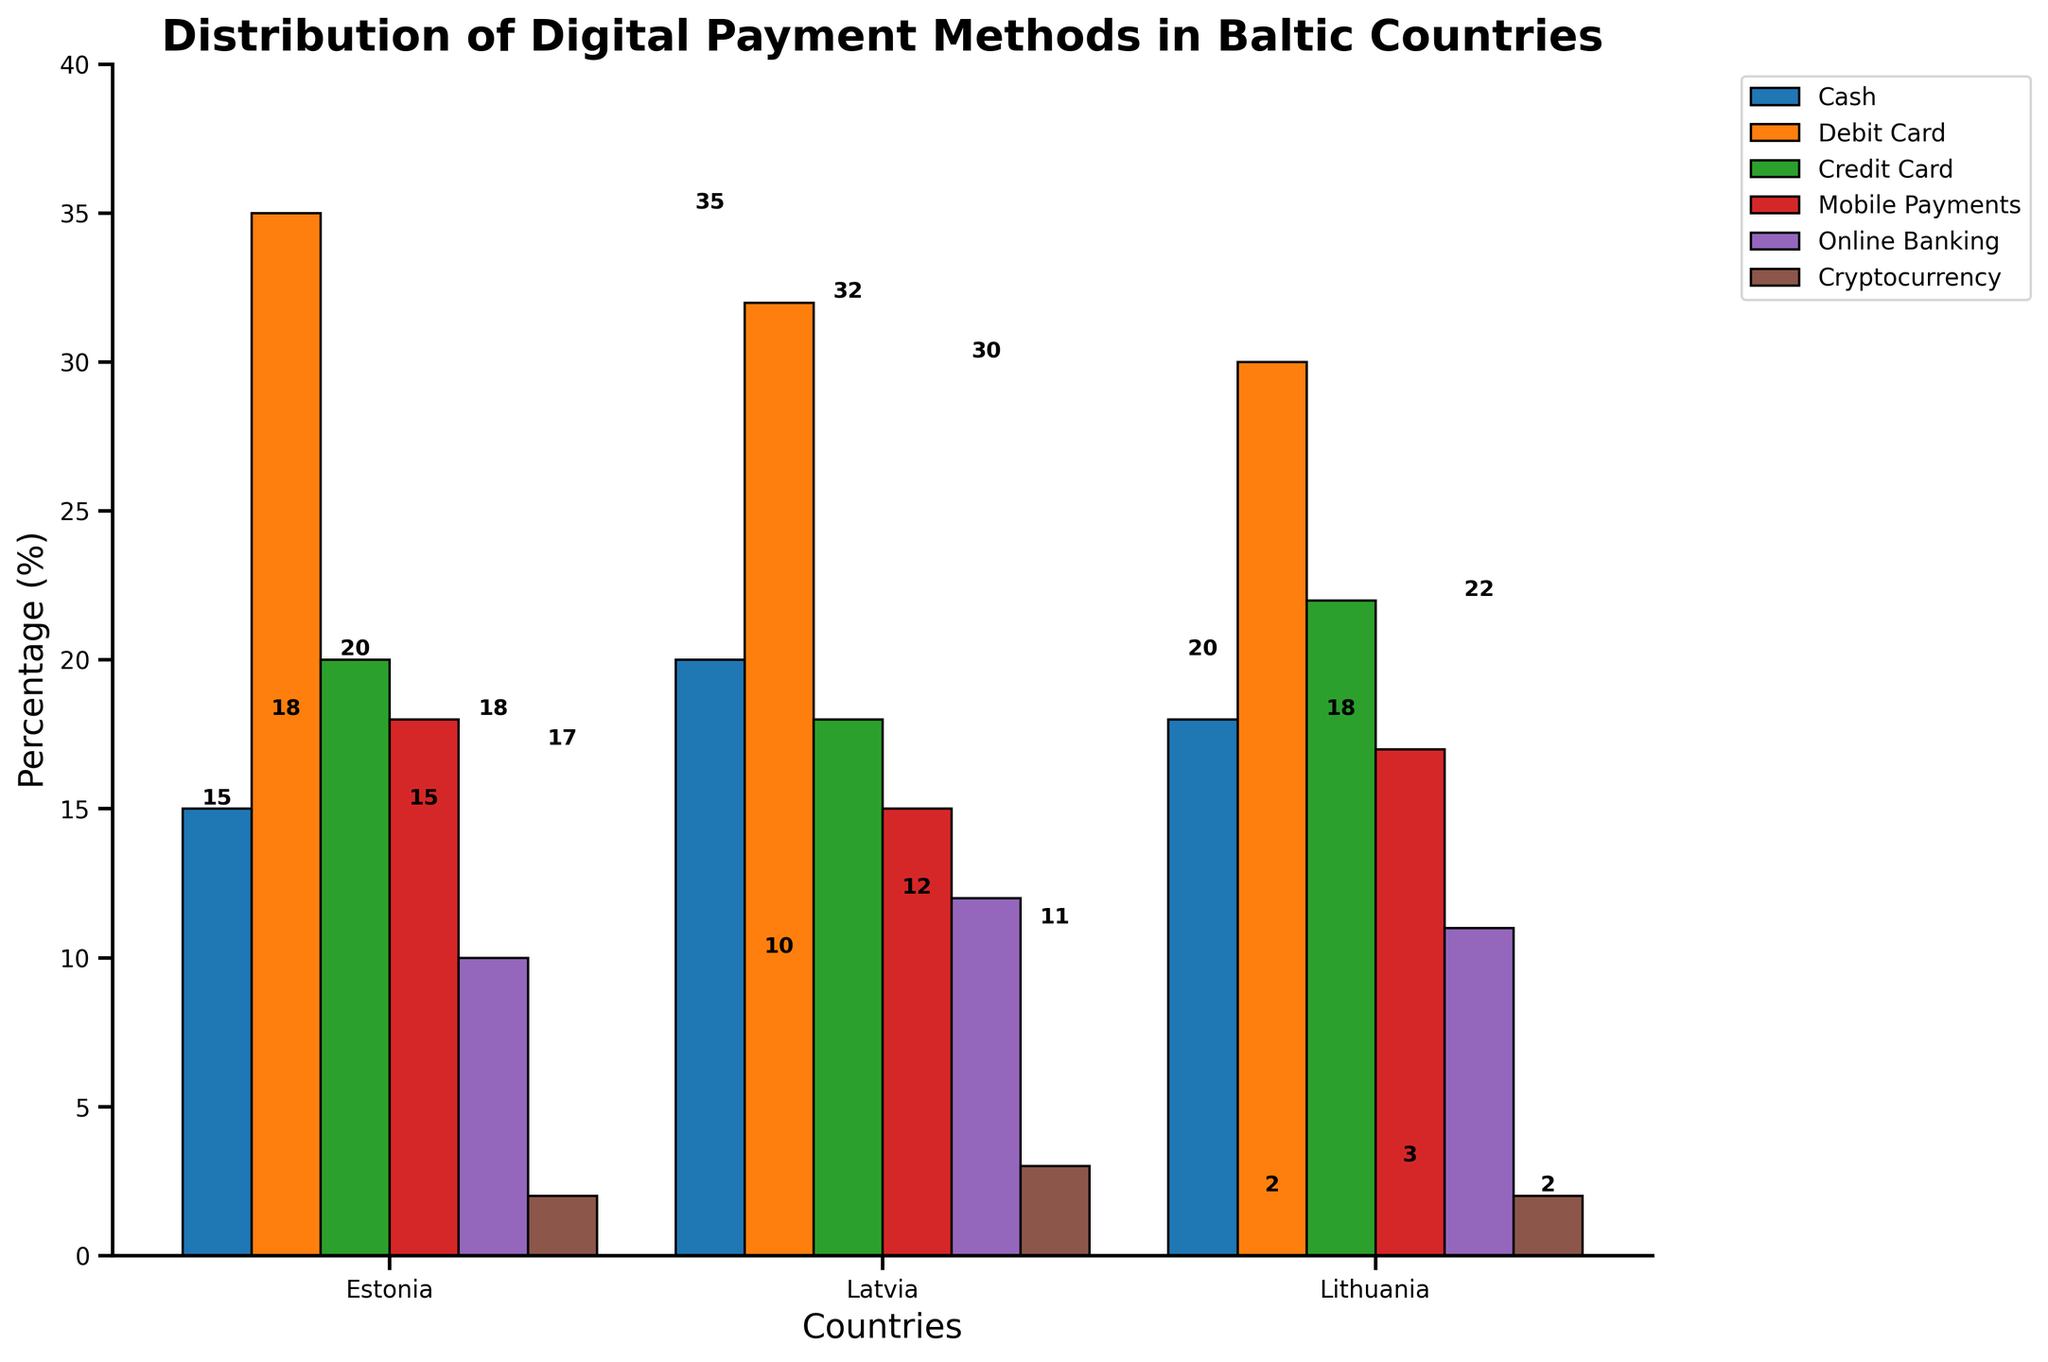Which country has the highest percentage of mobile payments? Estonia has 18%, Lithuania has 17%, and Latvia has 15%, so Estonia has the highest.
Answer: Estonia Which payment method is the least used in Latvia? Compare the values for each payment method in Latvia: Cash (20), Debit Card (32), Credit Card (18), Mobile Payments (15), Online Banking (12), Cryptocurrency (3). Cryptocurrency has the smallest percentage.
Answer: Cryptocurrency How does the percentage of debit card usage in Lithuania compare to Estonia? Debit card usage in Lithuania is 30% and in Estonia is 35%. Comparing these, Lithuania's debits card usage is 5% less than Estonia's.
Answer: Lithuania's debit card usage is 5% less What is the total percentage of cash and cryptocurrency usage in Estonia? Cash usage in Estonia is 15% and cryptocurrency is 2%. The total is 15% + 2% = 17%.
Answer: 17% What payment method is used the most in Estonia and what is its percentage? In Estonia, Debit Card is used the most with a percentage of 35%.
Answer: Debit Card, 35% Rank the countries by their usage of online banking from highest to lowest. Compare the online banking usage: Latvia (12%), Lithuania (11%), Estonia (10%). The ranking is Latvia > Lithuania > Estonia.
Answer: Latvia > Lithuania > Estonia Which country has the greatest difference between debit card and credit card usage? Estonia: 35% debit card - 20% credit card = 15%. Latvia: 32% debit card - 18% credit card = 14%. Lithuania: 30% debit card - 22% credit card = 8%. Estonia has the greatest difference of 15%.
Answer: Estonia Which payment method is equally used in both Estonia and Lithuania? Compare the values of each method: Cryptocurrency is 2% in both Estonia and Lithuania.
Answer: Cryptocurrency What is the average percentage of mobile payments across all three countries? Sum of mobile payments percentages: 18% (Estonia) + 15% (Latvia) + 17% (Lithuania) = 50%. The average is 50% / 3 = 16.67%.
Answer: 16.67% In which country is cash usage the second highest? Cash usage: Latvia (20%), Lithuania (18%), Estonia (15%). Second highest is Lithuania with 18%.
Answer: Lithuania 